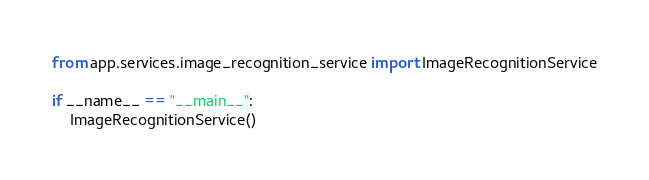Convert code to text. <code><loc_0><loc_0><loc_500><loc_500><_Python_>from app.services.image_recognition_service import ImageRecognitionService

if __name__ == "__main__":
    ImageRecognitionService()
</code> 